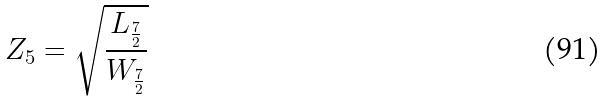<formula> <loc_0><loc_0><loc_500><loc_500>Z _ { 5 } = \sqrt { \frac { L _ { \frac { 7 } { 2 } } } { W _ { \frac { 7 } { 2 } } } }</formula> 